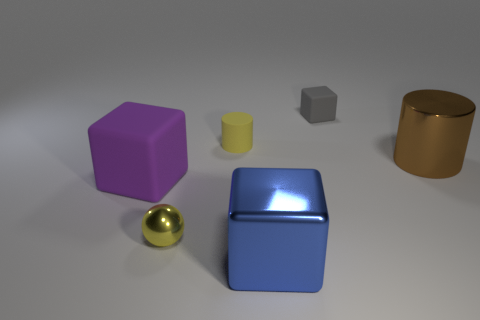Subtract all large blue cubes. How many cubes are left? 2 Subtract 2 cubes. How many cubes are left? 1 Subtract all blue cubes. How many cubes are left? 2 Subtract all balls. How many objects are left? 5 Add 1 big metallic objects. How many objects exist? 7 Subtract all gray spheres. Subtract all purple cylinders. How many spheres are left? 1 Subtract all yellow cubes. How many brown cylinders are left? 1 Subtract all big yellow matte balls. Subtract all large purple rubber objects. How many objects are left? 5 Add 6 tiny yellow rubber cylinders. How many tiny yellow rubber cylinders are left? 7 Add 5 cyan blocks. How many cyan blocks exist? 5 